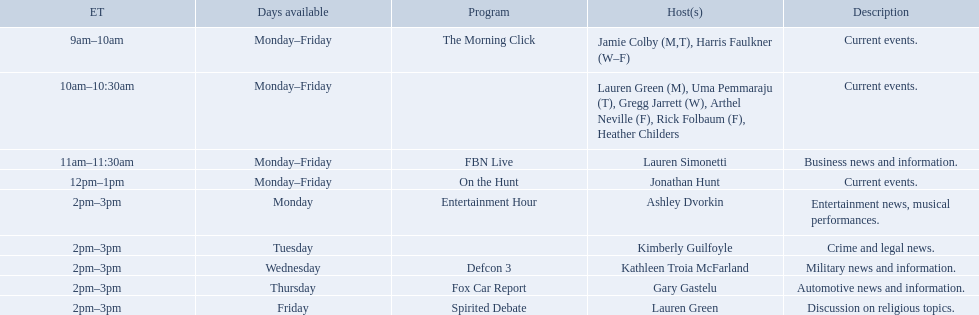Which programs broadcast by fox news channel hosts are listed? Jamie Colby (M,T), Harris Faulkner (W–F), Lauren Green (M), Uma Pemmaraju (T), Gregg Jarrett (W), Arthel Neville (F), Rick Folbaum (F), Heather Childers, Lauren Simonetti, Jonathan Hunt, Ashley Dvorkin, Kimberly Guilfoyle, Kathleen Troia McFarland, Gary Gastelu, Lauren Green. Of those, who have shows on friday? Jamie Colby (M,T), Harris Faulkner (W–F), Lauren Green (M), Uma Pemmaraju (T), Gregg Jarrett (W), Arthel Neville (F), Rick Folbaum (F), Heather Childers, Lauren Simonetti, Jonathan Hunt, Lauren Green. Of those, whose is at 2 pm? Lauren Green. Who are all the presenters? Jamie Colby (M,T), Harris Faulkner (W–F), Lauren Green (M), Uma Pemmaraju (T), Gregg Jarrett (W), Arthel Neville (F), Rick Folbaum (F), Heather Childers, Lauren Simonetti, Jonathan Hunt, Ashley Dvorkin, Kimberly Guilfoyle, Kathleen Troia McFarland, Gary Gastelu, Lauren Green. Which presenters have programs on fridays? Jamie Colby (M,T), Harris Faulkner (W–F), Lauren Green (M), Uma Pemmaraju (T), Gregg Jarrett (W), Arthel Neville (F), Rick Folbaum (F), Heather Childers, Lauren Simonetti, Jonathan Hunt, Lauren Green. Of those, which presenter's program broadcasts at 2pm? Lauren Green. Which programs aired by fox news channel presenters are mentioned? Jamie Colby (M,T), Harris Faulkner (W–F), Lauren Green (M), Uma Pemmaraju (T), Gregg Jarrett (W), Arthel Neville (F), Rick Folbaum (F), Heather Childers, Lauren Simonetti, Jonathan Hunt, Ashley Dvorkin, Kimberly Guilfoyle, Kathleen Troia McFarland, Gary Gastelu, Lauren Green. Of these, who have programs on friday? Jamie Colby (M,T), Harris Faulkner (W–F), Lauren Green (M), Uma Pemmaraju (T), Gregg Jarrett (W), Arthel Neville (F), Rick Folbaum (F), Heather Childers, Lauren Simonetti, Jonathan Hunt, Lauren Green. Of these, whose show is at 2 pm? Lauren Green. Which shows presented by fox news channel hosts are enumerated? Jamie Colby (M,T), Harris Faulkner (W–F), Lauren Green (M), Uma Pemmaraju (T), Gregg Jarrett (W), Arthel Neville (F), Rick Folbaum (F), Heather Childers, Lauren Simonetti, Jonathan Hunt, Ashley Dvorkin, Kimberly Guilfoyle, Kathleen Troia McFarland, Gary Gastelu, Lauren Green. Among them, who have episodes on friday? Jamie Colby (M,T), Harris Faulkner (W–F), Lauren Green (M), Uma Pemmaraju (T), Gregg Jarrett (W), Arthel Neville (F), Rick Folbaum (F), Heather Childers, Lauren Simonetti, Jonathan Hunt, Lauren Green. From them, whose occurs at 2 pm? Lauren Green. Who are all the presenters? Jamie Colby (M,T), Harris Faulkner (W–F), Lauren Green (M), Uma Pemmaraju (T), Gregg Jarrett (W), Arthel Neville (F), Rick Folbaum (F), Heather Childers, Lauren Simonetti, Jonathan Hunt, Ashley Dvorkin, Kimberly Guilfoyle, Kathleen Troia McFarland, Gary Gastelu, Lauren Green. Which presenters have programs on fridays? Jamie Colby (M,T), Harris Faulkner (W–F), Lauren Green (M), Uma Pemmaraju (T), Gregg Jarrett (W), Arthel Neville (F), Rick Folbaum (F), Heather Childers, Lauren Simonetti, Jonathan Hunt, Lauren Green. Among them, whose show is broadcasted at 2pm? Lauren Green. 